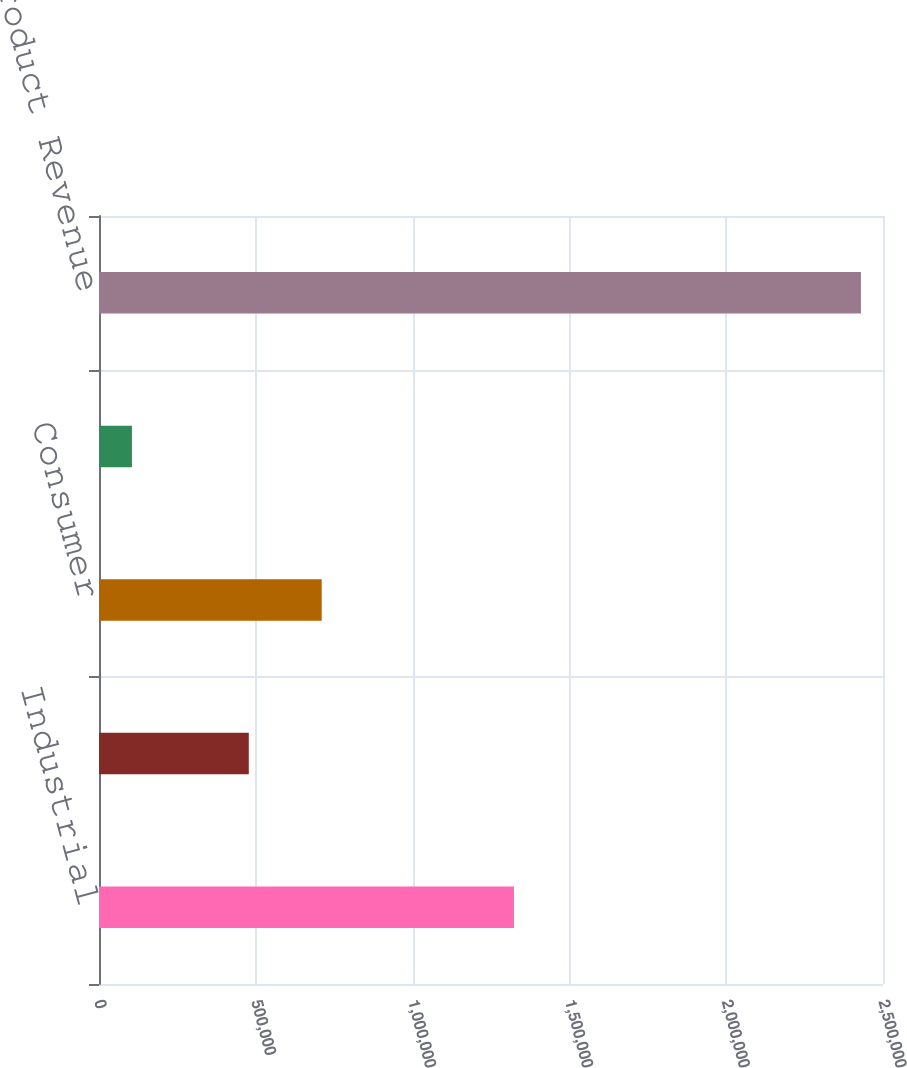Convert chart to OTSL. <chart><loc_0><loc_0><loc_500><loc_500><bar_chart><fcel>Industrial<fcel>Communications<fcel>Consumer<fcel>Computer<fcel>Total Product Revenue<nl><fcel>1.32325e+06<fcel>477645<fcel>710114<fcel>105031<fcel>2.42972e+06<nl></chart> 